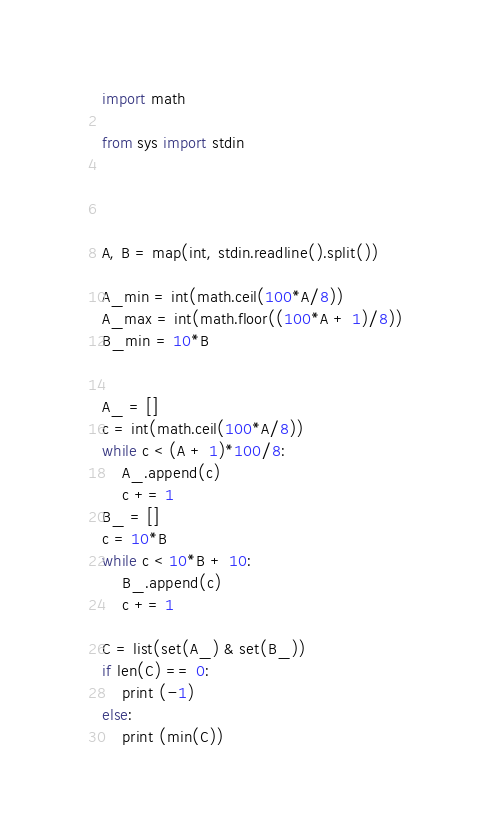<code> <loc_0><loc_0><loc_500><loc_500><_Python_>import math 

from sys import stdin
 



A, B = map(int, stdin.readline().split())

A_min = int(math.ceil(100*A/8))
A_max = int(math.floor((100*A + 1)/8))
B_min = 10*B 


A_ = []
c = int(math.ceil(100*A/8))
while c < (A + 1)*100/8:
	A_.append(c)
	c += 1
B_ = []
c = 10*B 
while c < 10*B + 10:
	B_.append(c)
	c += 1 

C = list(set(A_) & set(B_))
if len(C) == 0:
	print (-1)
else:
	print (min(C))</code> 